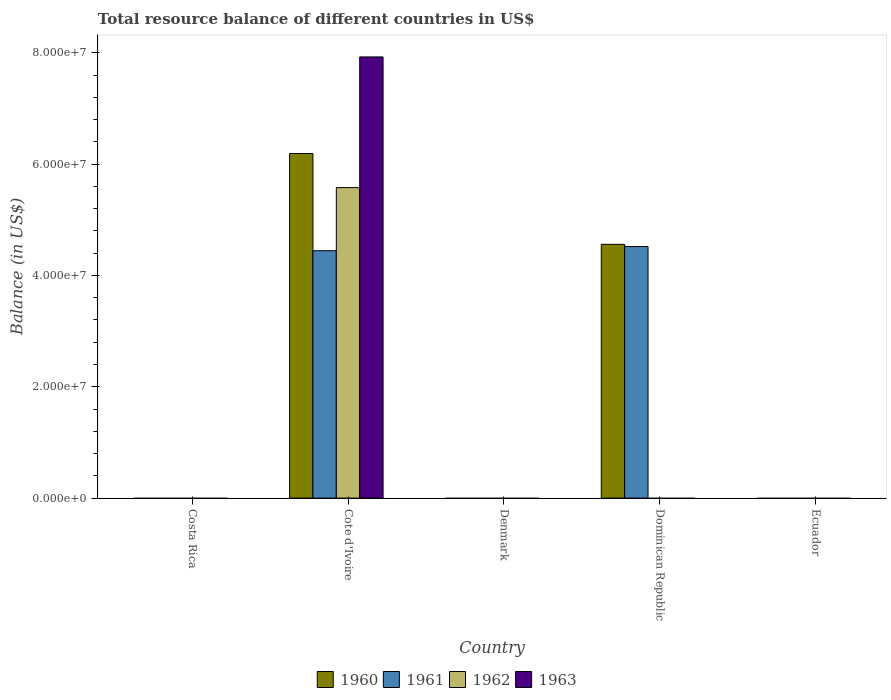Are the number of bars on each tick of the X-axis equal?
Provide a short and direct response. No. What is the label of the 2nd group of bars from the left?
Your answer should be compact. Cote d'Ivoire. What is the total resource balance in 1960 in Cote d'Ivoire?
Offer a very short reply. 6.19e+07. Across all countries, what is the maximum total resource balance in 1961?
Offer a very short reply. 4.52e+07. Across all countries, what is the minimum total resource balance in 1960?
Your answer should be compact. 0. In which country was the total resource balance in 1960 maximum?
Your answer should be very brief. Cote d'Ivoire. What is the total total resource balance in 1962 in the graph?
Provide a short and direct response. 5.58e+07. What is the difference between the total resource balance in 1962 in Ecuador and the total resource balance in 1960 in Denmark?
Provide a short and direct response. 0. What is the average total resource balance in 1962 per country?
Your answer should be compact. 1.12e+07. What is the difference between the total resource balance of/in 1962 and total resource balance of/in 1960 in Cote d'Ivoire?
Your answer should be very brief. -6.12e+06. What is the ratio of the total resource balance in 1960 in Cote d'Ivoire to that in Dominican Republic?
Make the answer very short. 1.36. What is the difference between the highest and the lowest total resource balance in 1960?
Your answer should be very brief. 6.19e+07. In how many countries, is the total resource balance in 1962 greater than the average total resource balance in 1962 taken over all countries?
Provide a succinct answer. 1. Is it the case that in every country, the sum of the total resource balance in 1960 and total resource balance in 1961 is greater than the sum of total resource balance in 1963 and total resource balance in 1962?
Your response must be concise. No. Is it the case that in every country, the sum of the total resource balance in 1961 and total resource balance in 1963 is greater than the total resource balance in 1962?
Give a very brief answer. No. How many bars are there?
Keep it short and to the point. 6. Are all the bars in the graph horizontal?
Keep it short and to the point. No. How many countries are there in the graph?
Offer a very short reply. 5. Does the graph contain any zero values?
Make the answer very short. Yes. Does the graph contain grids?
Provide a succinct answer. No. How many legend labels are there?
Keep it short and to the point. 4. What is the title of the graph?
Provide a succinct answer. Total resource balance of different countries in US$. Does "1964" appear as one of the legend labels in the graph?
Make the answer very short. No. What is the label or title of the X-axis?
Your response must be concise. Country. What is the label or title of the Y-axis?
Give a very brief answer. Balance (in US$). What is the Balance (in US$) in 1961 in Costa Rica?
Ensure brevity in your answer.  0. What is the Balance (in US$) of 1963 in Costa Rica?
Your response must be concise. 0. What is the Balance (in US$) of 1960 in Cote d'Ivoire?
Offer a terse response. 6.19e+07. What is the Balance (in US$) in 1961 in Cote d'Ivoire?
Offer a terse response. 4.44e+07. What is the Balance (in US$) of 1962 in Cote d'Ivoire?
Provide a succinct answer. 5.58e+07. What is the Balance (in US$) in 1963 in Cote d'Ivoire?
Your answer should be compact. 7.93e+07. What is the Balance (in US$) of 1960 in Denmark?
Offer a terse response. 0. What is the Balance (in US$) of 1961 in Denmark?
Your response must be concise. 0. What is the Balance (in US$) of 1960 in Dominican Republic?
Your answer should be compact. 4.56e+07. What is the Balance (in US$) of 1961 in Dominican Republic?
Give a very brief answer. 4.52e+07. What is the Balance (in US$) of 1962 in Dominican Republic?
Your response must be concise. 0. What is the Balance (in US$) of 1963 in Dominican Republic?
Your answer should be compact. 0. What is the Balance (in US$) of 1960 in Ecuador?
Provide a short and direct response. 0. What is the Balance (in US$) of 1961 in Ecuador?
Offer a terse response. 0. What is the Balance (in US$) in 1962 in Ecuador?
Make the answer very short. 0. Across all countries, what is the maximum Balance (in US$) in 1960?
Your answer should be very brief. 6.19e+07. Across all countries, what is the maximum Balance (in US$) of 1961?
Provide a succinct answer. 4.52e+07. Across all countries, what is the maximum Balance (in US$) in 1962?
Your answer should be compact. 5.58e+07. Across all countries, what is the maximum Balance (in US$) in 1963?
Your answer should be compact. 7.93e+07. Across all countries, what is the minimum Balance (in US$) in 1962?
Make the answer very short. 0. What is the total Balance (in US$) of 1960 in the graph?
Give a very brief answer. 1.08e+08. What is the total Balance (in US$) in 1961 in the graph?
Provide a succinct answer. 8.96e+07. What is the total Balance (in US$) in 1962 in the graph?
Your answer should be compact. 5.58e+07. What is the total Balance (in US$) in 1963 in the graph?
Your response must be concise. 7.93e+07. What is the difference between the Balance (in US$) in 1960 in Cote d'Ivoire and that in Dominican Republic?
Provide a succinct answer. 1.63e+07. What is the difference between the Balance (in US$) of 1961 in Cote d'Ivoire and that in Dominican Republic?
Keep it short and to the point. -7.54e+05. What is the difference between the Balance (in US$) in 1960 in Cote d'Ivoire and the Balance (in US$) in 1961 in Dominican Republic?
Provide a short and direct response. 1.67e+07. What is the average Balance (in US$) of 1960 per country?
Your answer should be very brief. 2.15e+07. What is the average Balance (in US$) of 1961 per country?
Your response must be concise. 1.79e+07. What is the average Balance (in US$) of 1962 per country?
Keep it short and to the point. 1.12e+07. What is the average Balance (in US$) of 1963 per country?
Offer a very short reply. 1.59e+07. What is the difference between the Balance (in US$) of 1960 and Balance (in US$) of 1961 in Cote d'Ivoire?
Keep it short and to the point. 1.75e+07. What is the difference between the Balance (in US$) in 1960 and Balance (in US$) in 1962 in Cote d'Ivoire?
Your answer should be compact. 6.12e+06. What is the difference between the Balance (in US$) of 1960 and Balance (in US$) of 1963 in Cote d'Ivoire?
Give a very brief answer. -1.74e+07. What is the difference between the Balance (in US$) of 1961 and Balance (in US$) of 1962 in Cote d'Ivoire?
Your answer should be compact. -1.13e+07. What is the difference between the Balance (in US$) of 1961 and Balance (in US$) of 1963 in Cote d'Ivoire?
Offer a very short reply. -3.48e+07. What is the difference between the Balance (in US$) in 1962 and Balance (in US$) in 1963 in Cote d'Ivoire?
Offer a terse response. -2.35e+07. What is the ratio of the Balance (in US$) of 1960 in Cote d'Ivoire to that in Dominican Republic?
Offer a very short reply. 1.36. What is the ratio of the Balance (in US$) in 1961 in Cote d'Ivoire to that in Dominican Republic?
Provide a succinct answer. 0.98. What is the difference between the highest and the lowest Balance (in US$) in 1960?
Keep it short and to the point. 6.19e+07. What is the difference between the highest and the lowest Balance (in US$) in 1961?
Provide a succinct answer. 4.52e+07. What is the difference between the highest and the lowest Balance (in US$) of 1962?
Your answer should be very brief. 5.58e+07. What is the difference between the highest and the lowest Balance (in US$) in 1963?
Offer a terse response. 7.93e+07. 